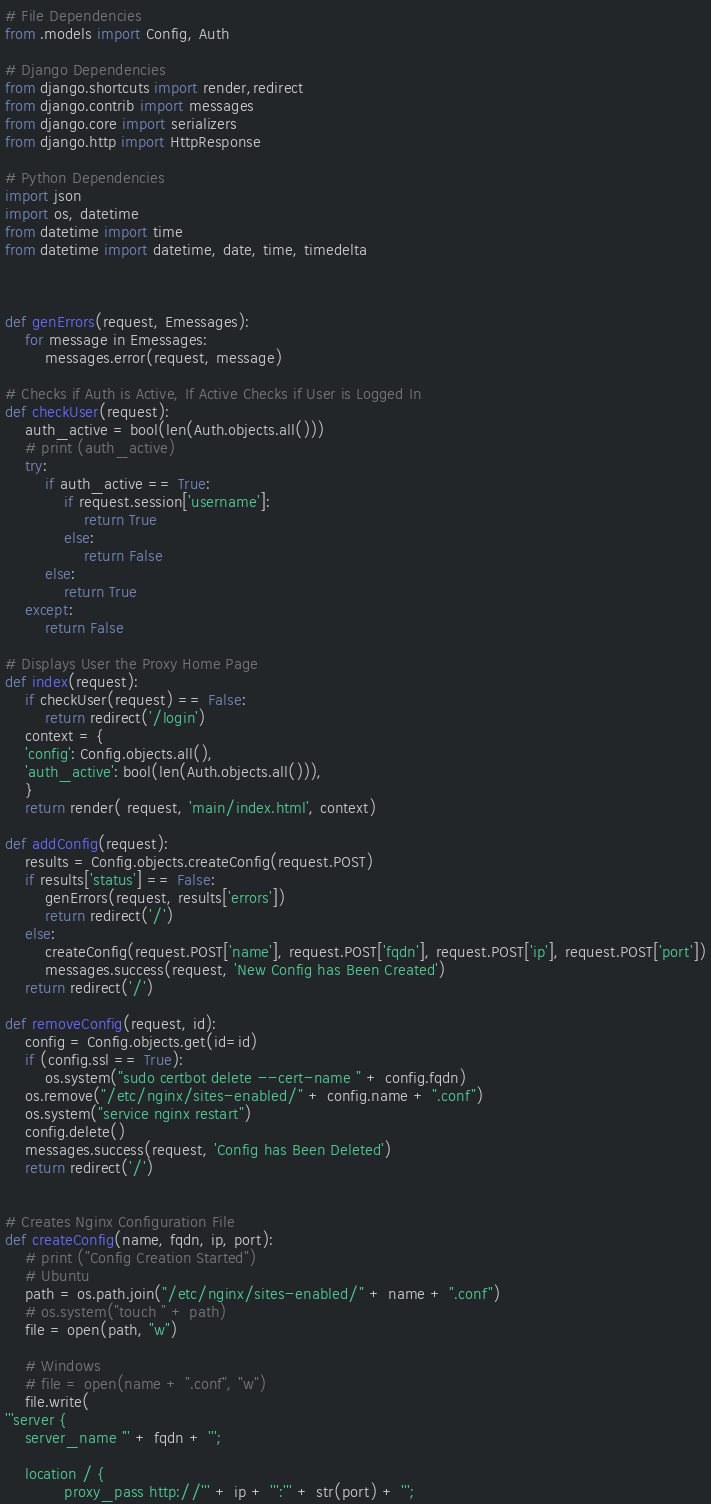Convert code to text. <code><loc_0><loc_0><loc_500><loc_500><_Python_># File Dependencies
from .models import Config, Auth

# Django Dependencies
from django.shortcuts import render,redirect
from django.contrib import messages
from django.core import serializers
from django.http import HttpResponse

# Python Dependencies
import json
import os, datetime
from datetime import time  
from datetime import datetime, date, time, timedelta



def genErrors(request, Emessages):
	for message in Emessages:
		messages.error(request, message)

# Checks if Auth is Active, If Active Checks if User is Logged In
def checkUser(request):
	auth_active = bool(len(Auth.objects.all()))
	# print (auth_active)
	try:
		if auth_active == True:
			if request.session['username']:
				return True
			else:
				return False
		else:
			return True
	except:
		return False
	
# Displays User the Proxy Home Page
def index(request):
	if checkUser(request) == False:
		return redirect('/login')
	context = {
	'config': Config.objects.all(),
	'auth_active': bool(len(Auth.objects.all())),
	}
	return render( request, 'main/index.html', context)

def addConfig(request):
	results = Config.objects.createConfig(request.POST)
	if results['status'] == False:
		genErrors(request, results['errors'])
		return redirect('/')
	else:
		createConfig(request.POST['name'], request.POST['fqdn'], request.POST['ip'], request.POST['port'])
		messages.success(request, 'New Config has Been Created')
	return redirect('/')

def removeConfig(request, id):
	config = Config.objects.get(id=id)
	if (config.ssl == True):
		os.system("sudo certbot delete --cert-name " + config.fqdn)
	os.remove("/etc/nginx/sites-enabled/" + config.name + ".conf")
	os.system("service nginx restart")
	config.delete()
	messages.success(request, 'Config has Been Deleted')
	return redirect('/')


# Creates Nginx Configuration File
def createConfig(name, fqdn, ip, port):
	# print ("Config Creation Started")
	# Ubuntu
	path = os.path.join("/etc/nginx/sites-enabled/" + name + ".conf")
	# os.system("touch " + path)
	file = open(path, "w")

	# Windows
	# file = open(name + ".conf", "w")
	file.write(
'''server {
    server_name ''' + fqdn + ''';
 
    location / {
            proxy_pass http://''' + ip + ''':''' + str(port) + ''';</code> 